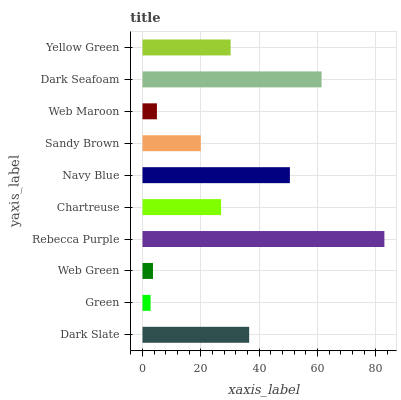Is Green the minimum?
Answer yes or no. Yes. Is Rebecca Purple the maximum?
Answer yes or no. Yes. Is Web Green the minimum?
Answer yes or no. No. Is Web Green the maximum?
Answer yes or no. No. Is Web Green greater than Green?
Answer yes or no. Yes. Is Green less than Web Green?
Answer yes or no. Yes. Is Green greater than Web Green?
Answer yes or no. No. Is Web Green less than Green?
Answer yes or no. No. Is Yellow Green the high median?
Answer yes or no. Yes. Is Chartreuse the low median?
Answer yes or no. Yes. Is Web Green the high median?
Answer yes or no. No. Is Web Green the low median?
Answer yes or no. No. 